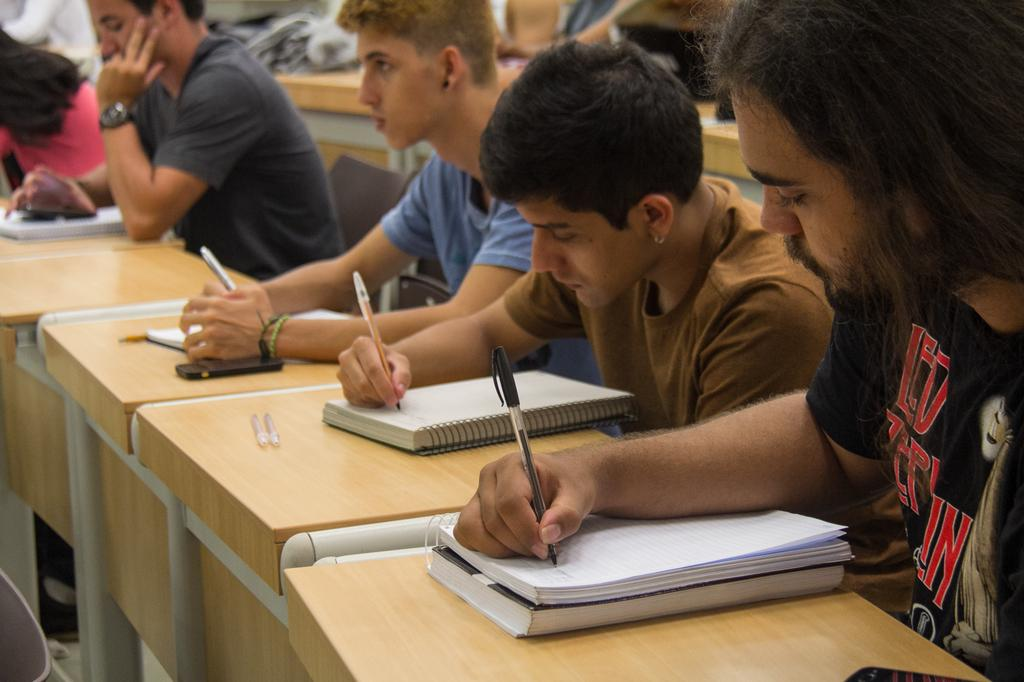<image>
Render a clear and concise summary of the photo. Students are taking notes, including a boy with a Led Zeppelin t-shirt. 